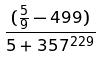Convert formula to latex. <formula><loc_0><loc_0><loc_500><loc_500>\frac { ( \frac { 5 } { 9 } - 4 9 9 ) } { 5 + 3 5 7 ^ { 2 2 9 } }</formula> 